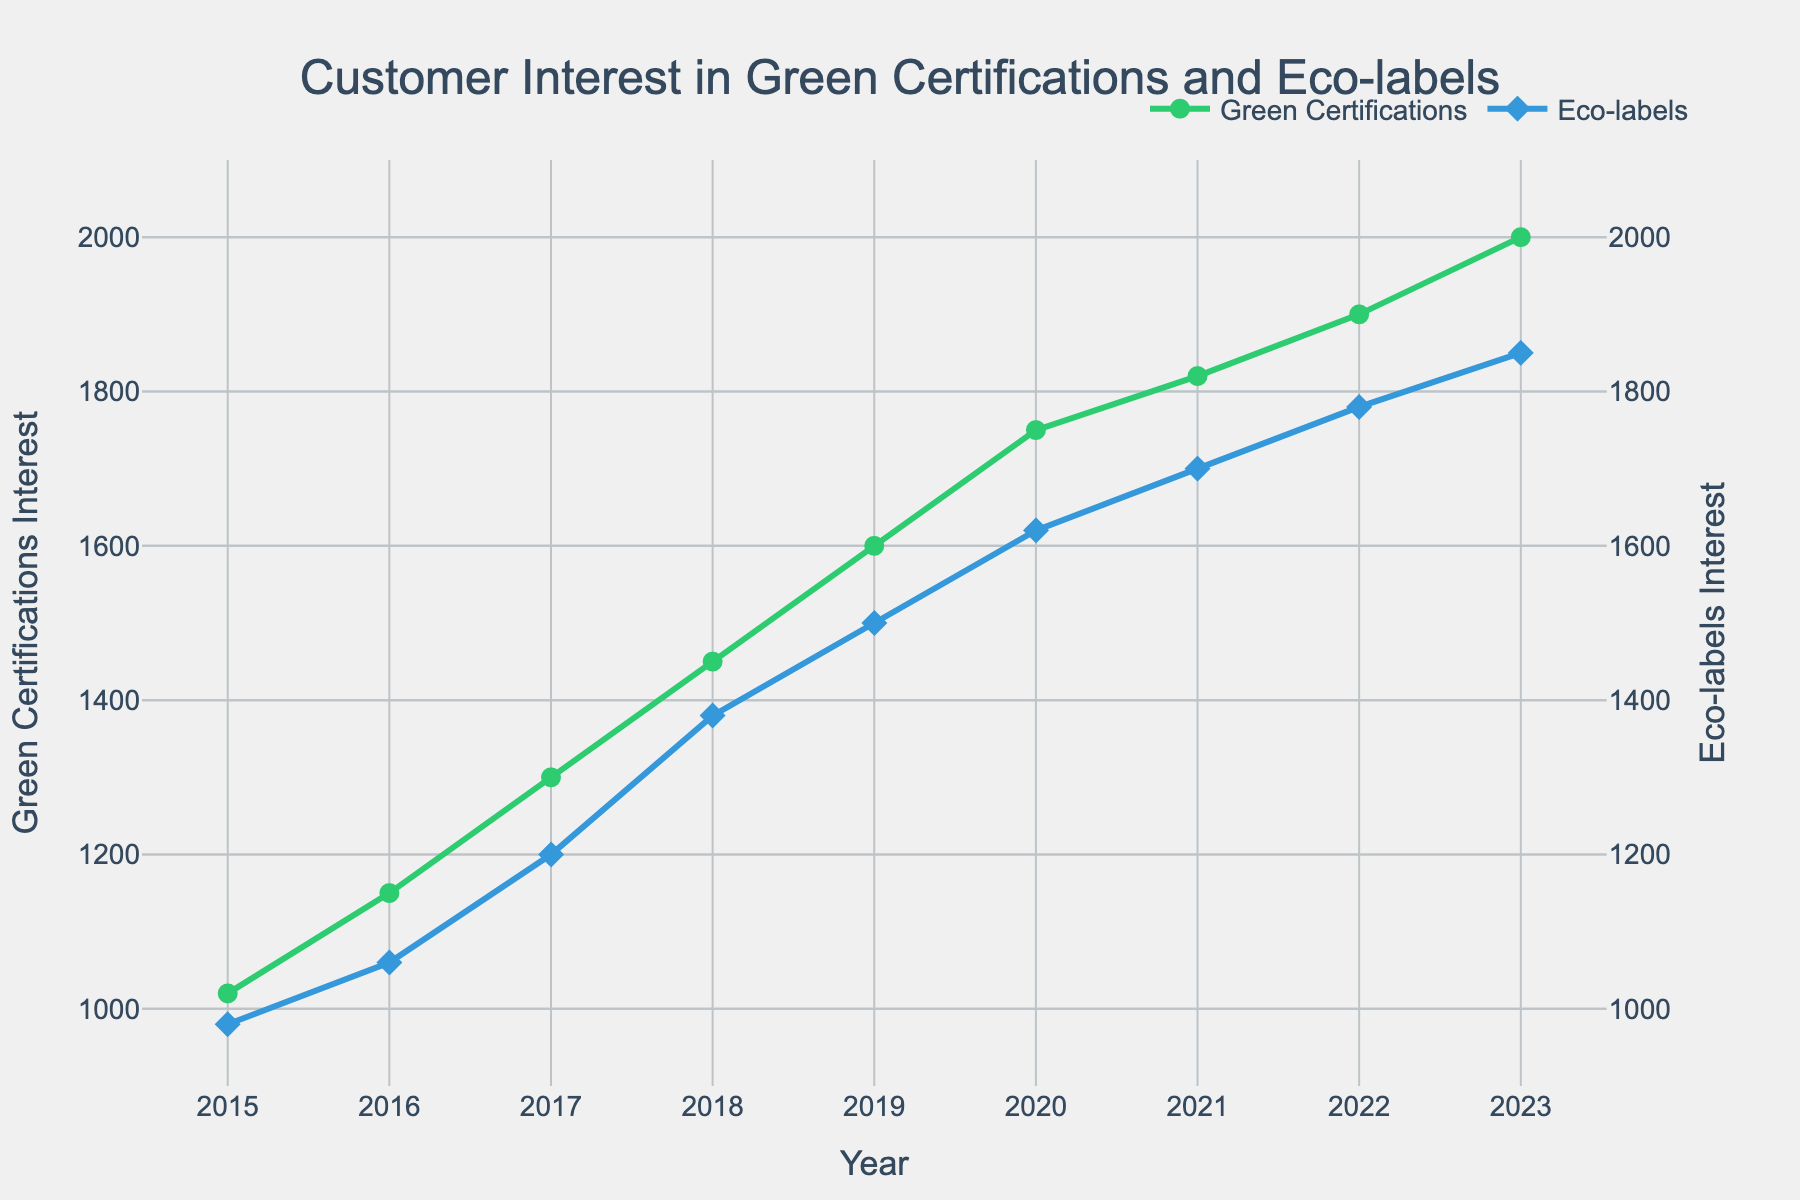How many data points are displayed for Green Certifications Interest? Count the number of data points marked by circles on the green line representing Green Certifications Interest.
Answer: 9 What is the title of the figure? Read the text at the top of the plot, which is centered and bold.
Answer: Customer Interest in Green Certifications and Eco-labels In which year did the Eco-labels Interest surpass 1500? Identify where the blue line for Eco-labels Interest crosses the 1500 mark on the y-axis and note the corresponding year on the x-axis.
Answer: 2019 What was the difference in interest between Green Certifications and Eco-labels in 2022? Subtract the value of Eco-labels Interest in 2022 from the value of Green Certifications Interest in the same year. Green Certifications (1900) - Eco-labels (1780).
Answer: 120 By how much did Green Certifications Interest increase from 2018 to 2021? Subtract the value of Green Certifications Interest in 2018 from the value in 2021. Green Certifications (1820) - Green Certifications (1450).
Answer: 370 What are the colors used for the lines representing Green Certifications and Eco-labels Interest? Observe the colors of the lines, the green line represents Green Certifications Interest and the blue line represents Eco-labels Interest.
Answer: Green and Blue Which year shows the highest customer interest in Eco-labels? Identify the peak of the blue line for Eco-labels Interest and note the corresponding year on the x-axis.
Answer: 2023 Did Green Certifications Interest ever decrease from one year to the next? Observe the trend of the green line representing Green Certifications Interest. It consistently increases every year.
Answer: No Which year had the lowest customer interest in both Green Certifications and Eco-labels? Find the minimum value points on both the green and blue lines and note the corresponding year on the x-axis.
Answer: 2015 How does the growth rate of Green Certifications Interest compare to that of Eco-labels Interest from 2015 to 2023? Calculate the annual growth rate for both Green Certifications and Eco-labels by dividing the overall increase by the number of years (8 years). Green Certifications growth: (2000 - 1020) / 8 = 122.5 per year. Eco-labels growth: (1850 - 980) / 8 = 108.75 per year. Green Certifications have a higher annual growth rate.
Answer: Green Certifications have a higher growth rate 